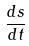<formula> <loc_0><loc_0><loc_500><loc_500>\frac { d s } { d t }</formula> 